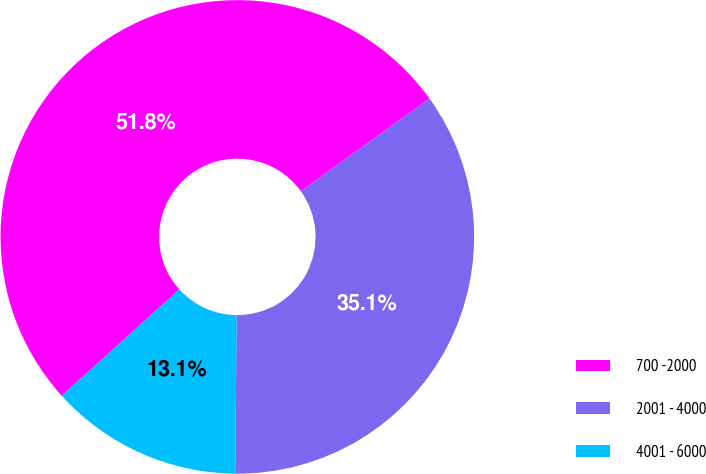<chart> <loc_0><loc_0><loc_500><loc_500><pie_chart><fcel>700 -2000<fcel>2001 - 4000<fcel>4001 - 6000<nl><fcel>51.78%<fcel>35.07%<fcel>13.15%<nl></chart> 